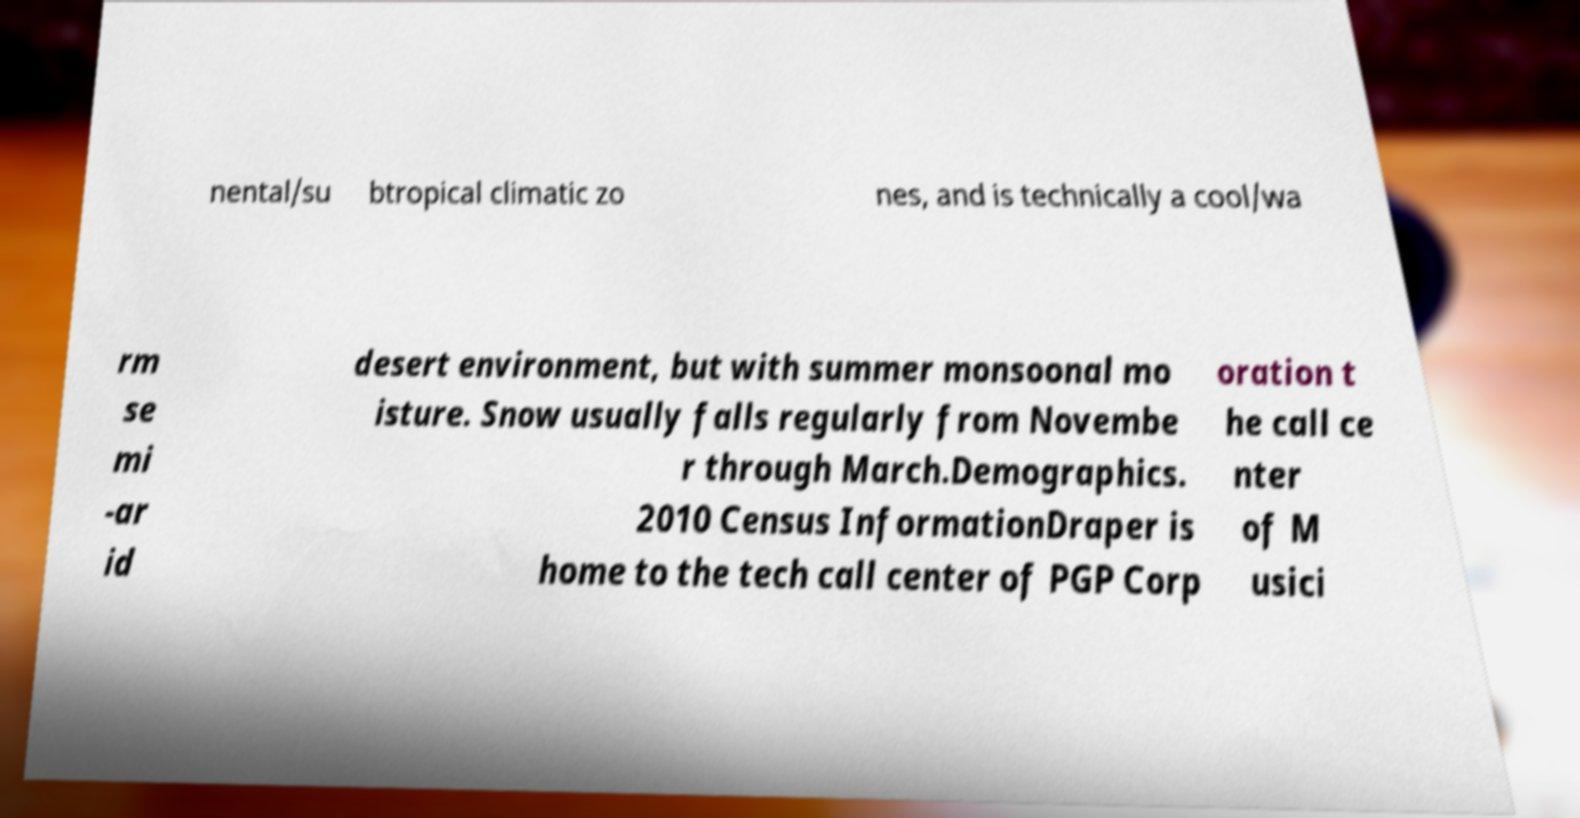Could you extract and type out the text from this image? nental/su btropical climatic zo nes, and is technically a cool/wa rm se mi -ar id desert environment, but with summer monsoonal mo isture. Snow usually falls regularly from Novembe r through March.Demographics. 2010 Census InformationDraper is home to the tech call center of PGP Corp oration t he call ce nter of M usici 